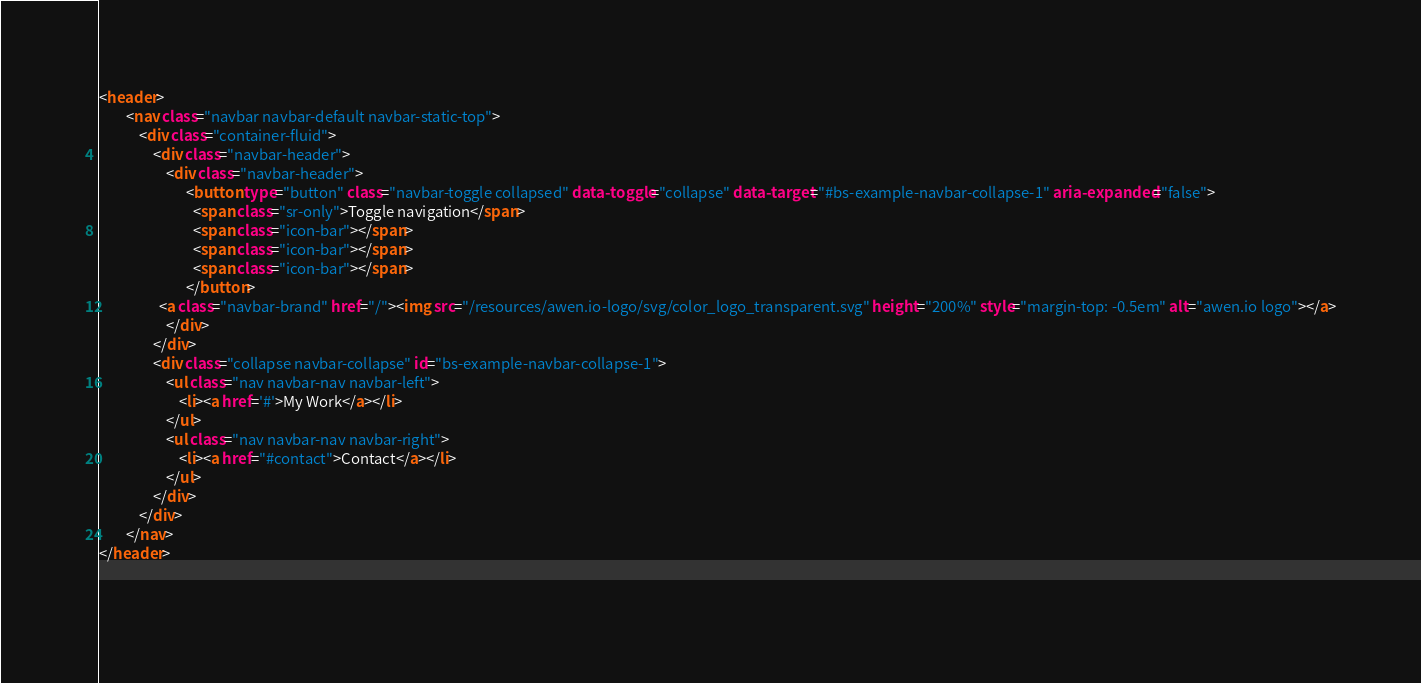<code> <loc_0><loc_0><loc_500><loc_500><_HTML_><header>
    	<nav class="navbar navbar-default navbar-static-top">
    		<div class="container-fluid">
    			<div class="navbar-header">
                    <div class="navbar-header">
                          <button type="button" class="navbar-toggle collapsed" data-toggle="collapse" data-target="#bs-example-navbar-collapse-1" aria-expanded="false">
                            <span class="sr-only">Toggle navigation</span>
                            <span class="icon-bar"></span>
                            <span class="icon-bar"></span>
                            <span class="icon-bar"></span>
                          </button>
				  <a class="navbar-brand" href="/"><img src="/resources/awen.io-logo/svg/color_logo_transparent.svg" height="200%" style="margin-top: -0.5em" alt="awen.io logo"></a>
                    </div>
    			</div>
                <div class="collapse navbar-collapse" id="bs-example-navbar-collapse-1">
        			<ul class="nav navbar-nav navbar-left">
        				<li><a href='#'>My Work</a></li>
        			</ul>
        			<ul class="nav navbar-nav navbar-right">
        				<li><a href="#contact">Contact</a></li>
        			</ul>
                </div>
    		</div>
    	</nav>
</header>

	
</code> 